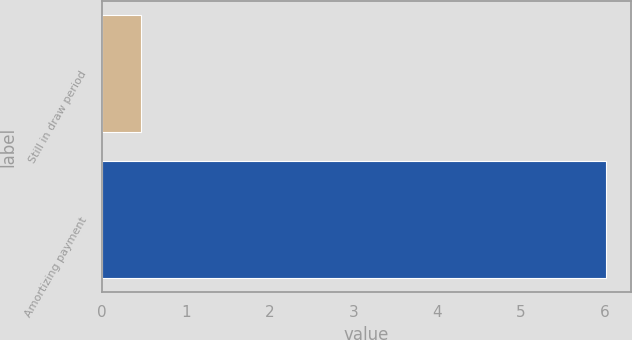Convert chart. <chart><loc_0><loc_0><loc_500><loc_500><bar_chart><fcel>Still in draw period<fcel>Amortizing payment<nl><fcel>0.47<fcel>6.01<nl></chart> 